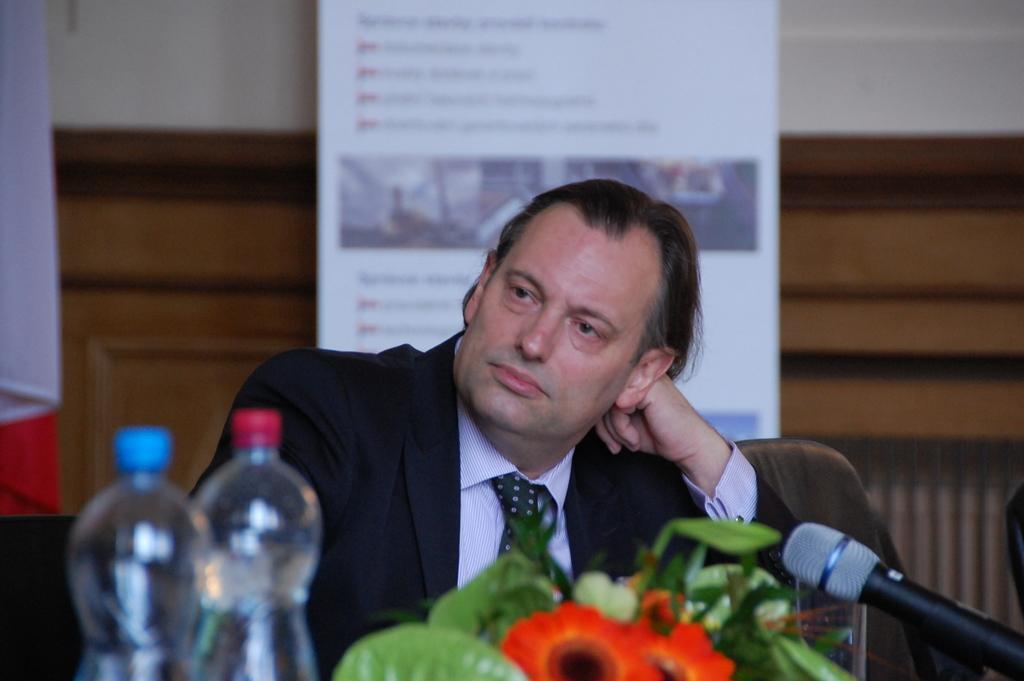Who is in the picture? There is a person in the picture. What is the person wearing? The person is wearing a black suit. What is the person doing in the picture? The person is sitting on a chair. Where is the chair located? The chair is in front of a table. What items can be seen on the table? There are two bottles, a plant, and a microphone on the table. What type of breakfast is being served in the image? There is no breakfast visible in the image. What day of the week is it in the image? The day of the week cannot be determined from the image. Are there any animals present in the image? There are no animals visible in the image. 